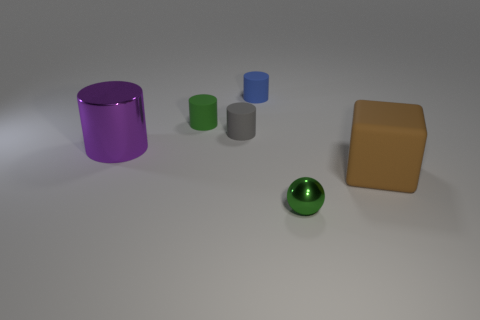Subtract 1 cylinders. How many cylinders are left? 3 Add 1 tiny brown cubes. How many objects exist? 7 Subtract all cylinders. How many objects are left? 2 Subtract all tiny gray rubber objects. Subtract all cylinders. How many objects are left? 1 Add 2 tiny green cylinders. How many tiny green cylinders are left? 3 Add 3 green balls. How many green balls exist? 4 Subtract 0 brown cylinders. How many objects are left? 6 